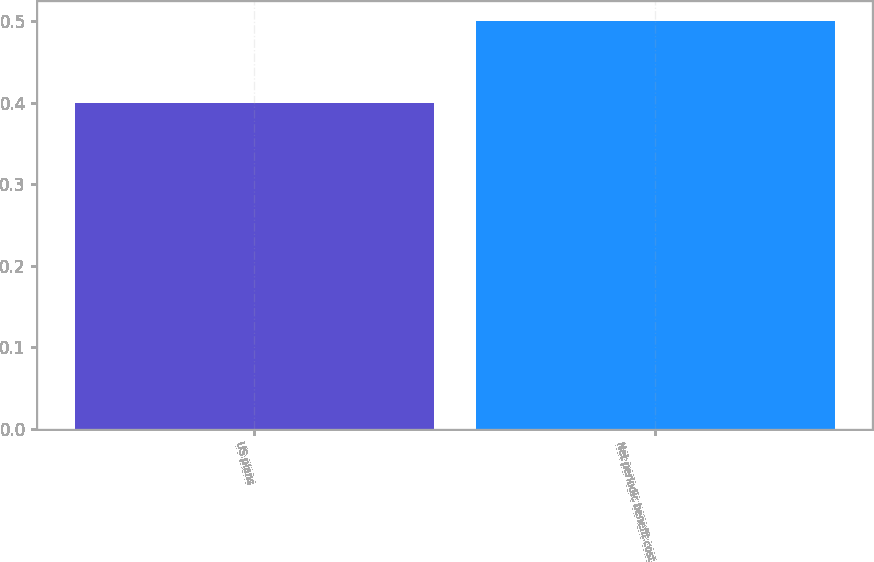Convert chart to OTSL. <chart><loc_0><loc_0><loc_500><loc_500><bar_chart><fcel>US plans<fcel>Net periodic benefit cost<nl><fcel>0.4<fcel>0.5<nl></chart> 